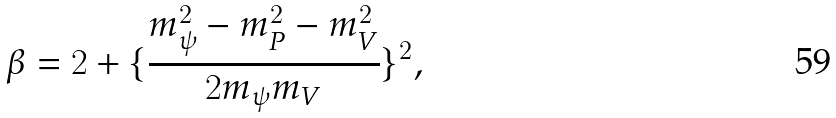<formula> <loc_0><loc_0><loc_500><loc_500>\beta = 2 + \{ \frac { m _ { \psi } ^ { 2 } - m _ { P } ^ { 2 } - m _ { V } ^ { 2 } } { 2 m _ { \psi } m _ { V } } \} ^ { 2 } ,</formula> 